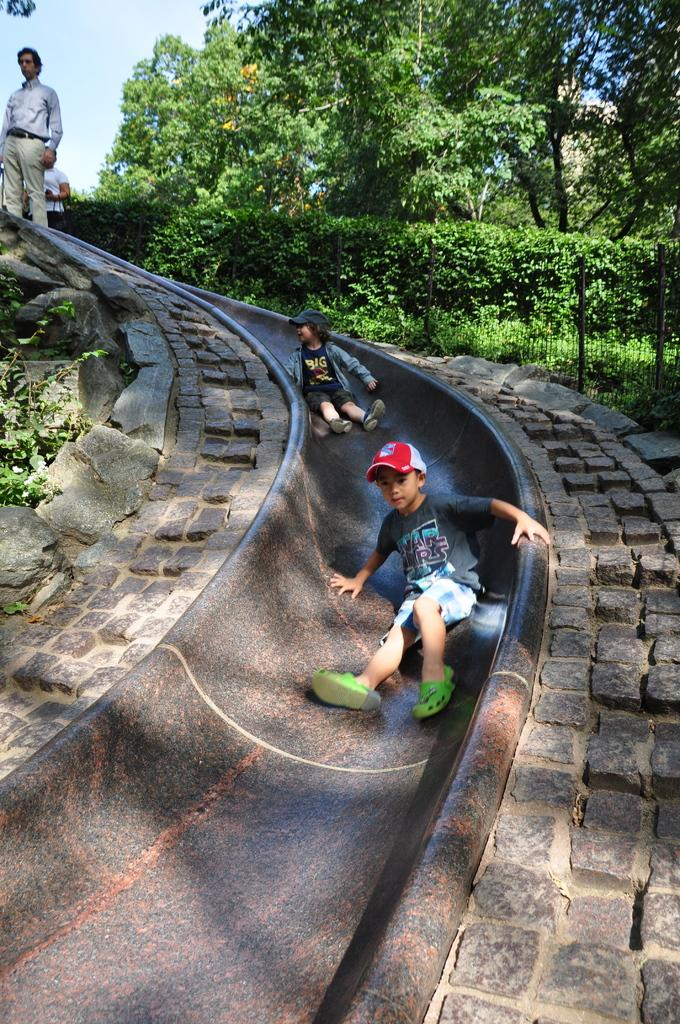Who is present in the image? There are people in the image. What are the kids doing in the image? Two kids are sitting on a slide. What type of vegetation can be seen in the image? There are plants and trees in the image. What is visible in the background of the image? The sky is visible in the background of the image. What invention is the sister holding in the image? There is no sister or invention present in the image. What type of rat can be seen interacting with the kids on the slide? There is no rat present in the image; only people, a slide, plants, trees, and the sky are visible. 